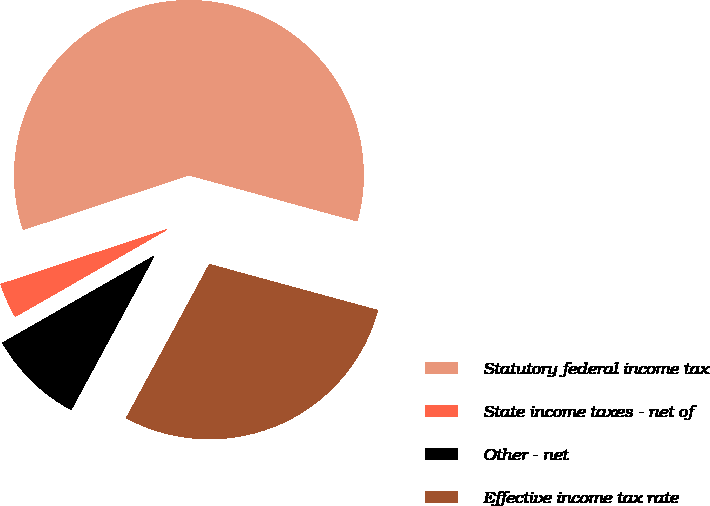Convert chart to OTSL. <chart><loc_0><loc_0><loc_500><loc_500><pie_chart><fcel>Statutory federal income tax<fcel>State income taxes - net of<fcel>Other - net<fcel>Effective income tax rate<nl><fcel>59.31%<fcel>3.22%<fcel>8.83%<fcel>28.64%<nl></chart> 